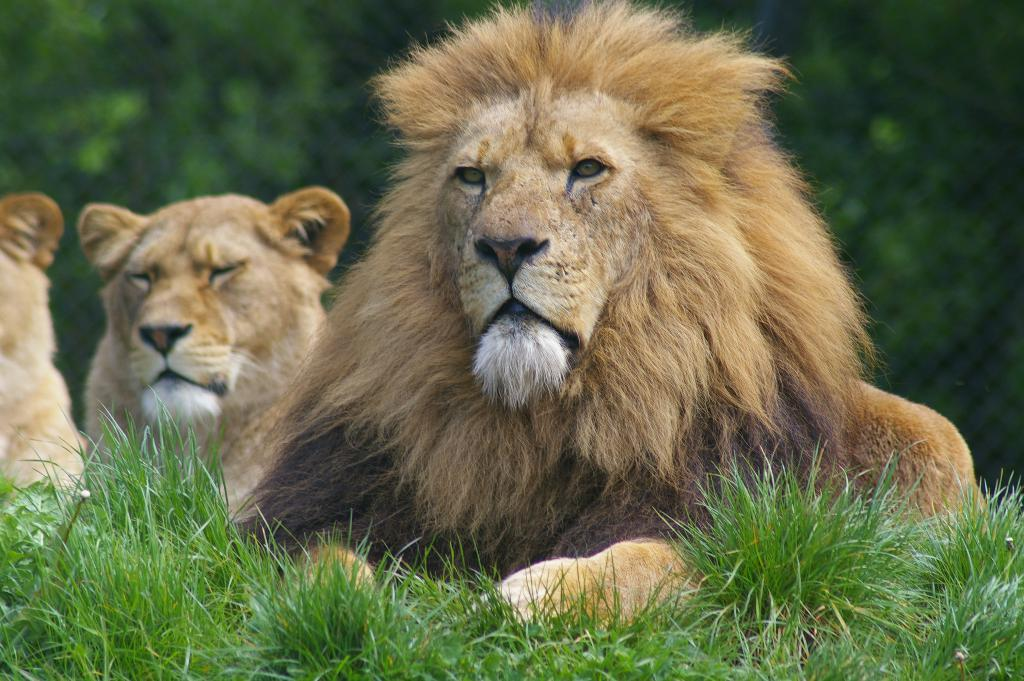What animal is in the center of the image? There is a lion in the center of the image. What type of environment is the lion in? The lion is on the grassland. Are there any other lions visible in the image? Yes, there are other lions in the background of the image. What can be seen in the background besides the lions? There is greenery in the background of the image. What type of bomb can be seen in the image? There is no bomb present in the image; it features a lion on the grassland with other lions in the background. 